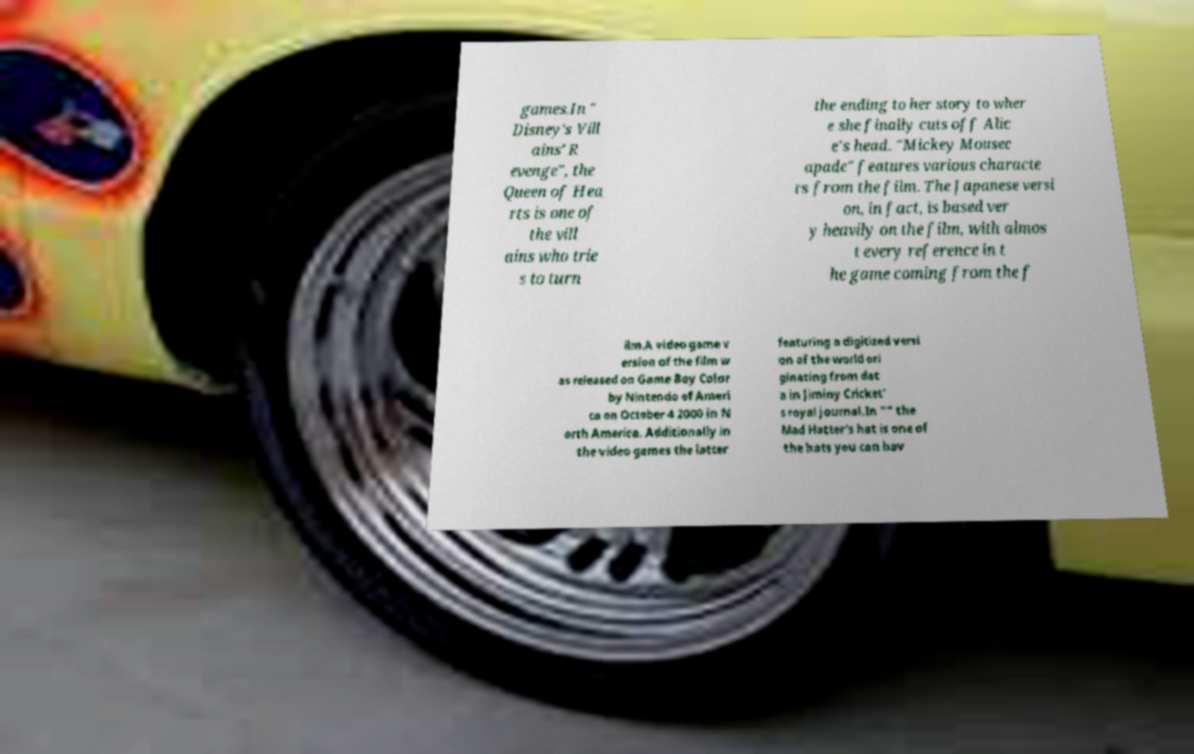For documentation purposes, I need the text within this image transcribed. Could you provide that? games.In " Disney's Vill ains' R evenge", the Queen of Hea rts is one of the vill ains who trie s to turn the ending to her story to wher e she finally cuts off Alic e's head. "Mickey Mousec apade" features various characte rs from the film. The Japanese versi on, in fact, is based ver y heavily on the film, with almos t every reference in t he game coming from the f ilm.A video game v ersion of the film w as released on Game Boy Color by Nintendo of Ameri ca on October 4 2000 in N orth America. Additionally in the video games the latter featuring a digitized versi on of the world ori ginating from dat a in Jiminy Cricket' s royal journal.In "" the Mad Hatter's hat is one of the hats you can hav 